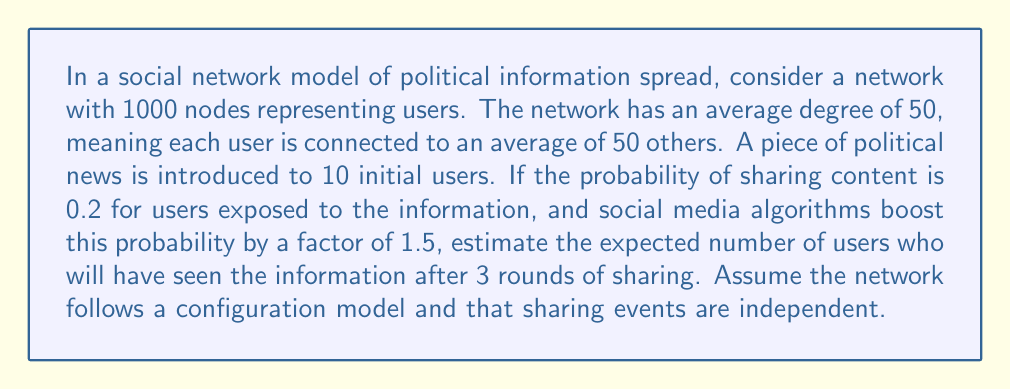Solve this math problem. To solve this problem, we'll use concepts from network theory and information diffusion models. Let's break it down step-by-step:

1) First, let's define our variables:
   $N = 1000$ (total nodes)
   $k = 50$ (average degree)
   $I_0 = 10$ (initial informed users)
   $p = 0.2$ (base probability of sharing)
   $b = 1.5$ (boost factor from algorithms)
   $p' = p * b = 0.3$ (boosted probability of sharing)

2) In each round, we need to calculate:
   a) The number of newly informed users
   b) The total number of informed users

3) For the configuration model with large N, we can approximate the probability of a random edge leading to an uninformed node as:

   $$P(\text{uninformed}) \approx \frac{N - I_t}{N}$$

   where $I_t$ is the number of informed users at time t.

4) The expected number of newly informed users in each round is:

   $$E(\text{new informed}) = I_t * k * p' * \frac{N - I_t}{N}$$

5) Let's calculate for each round:

   Round 1:
   $E(\text{new informed}) = 10 * 50 * 0.3 * \frac{1000 - 10}{1000} \approx 148.5$
   $I_1 = 10 + 148.5 = 158.5$

   Round 2:
   $E(\text{new informed}) = 158.5 * 50 * 0.3 * \frac{1000 - 158.5}{1000} \approx 2007.9$
   $I_2 = 158.5 + 2007.9 = 2166.4$

   Round 3:
   Since $I_2 > N$, everyone has been informed by the end of round 2.

6) Therefore, after 3 rounds, we expect all 1000 users to have seen the information.
Answer: 1000 users 